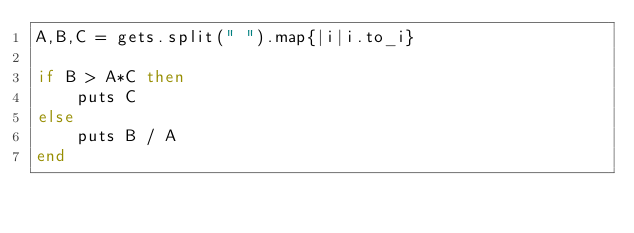Convert code to text. <code><loc_0><loc_0><loc_500><loc_500><_Ruby_>A,B,C = gets.split(" ").map{|i|i.to_i}

if B > A*C then
    puts C
else
    puts B / A
end</code> 